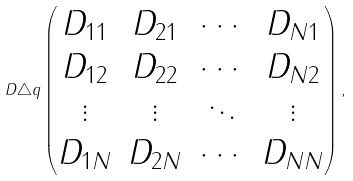Convert formula to latex. <formula><loc_0><loc_0><loc_500><loc_500>D \triangle q \begin{pmatrix} D _ { 1 1 } & D _ { 2 1 } & \cdots & D _ { N 1 } \\ D _ { 1 2 } & D _ { 2 2 } & \cdots & D _ { N 2 } \\ \vdots & \vdots & \ddots & \vdots \\ D _ { 1 N } & D _ { 2 N } & \cdots & D _ { N N } \end{pmatrix} ,</formula> 